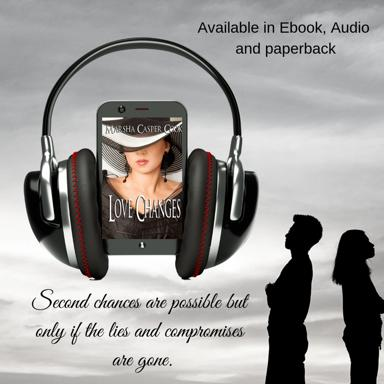Aside from the main theme of second chances, what subthemes might the novel explore based on the image? The juxtaposition of the headphones and various formats of the book could hint at themes of adaptability and the modernization of relationships, suggesting that as technology evolves, so too must the ways in which people connect and reconcile. 